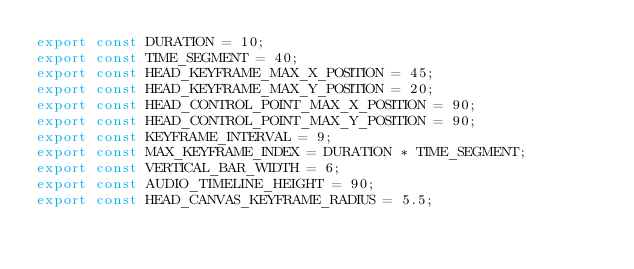<code> <loc_0><loc_0><loc_500><loc_500><_JavaScript_>export const DURATION = 10;
export const TIME_SEGMENT = 40;
export const HEAD_KEYFRAME_MAX_X_POSITION = 45;
export const HEAD_KEYFRAME_MAX_Y_POSITION = 20;
export const HEAD_CONTROL_POINT_MAX_X_POSITION = 90;
export const HEAD_CONTROL_POINT_MAX_Y_POSITION = 90;
export const KEYFRAME_INTERVAL = 9;
export const MAX_KEYFRAME_INDEX = DURATION * TIME_SEGMENT;
export const VERTICAL_BAR_WIDTH = 6;
export const AUDIO_TIMELINE_HEIGHT = 90;
export const HEAD_CANVAS_KEYFRAME_RADIUS = 5.5;
</code> 